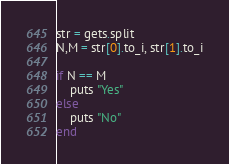Convert code to text. <code><loc_0><loc_0><loc_500><loc_500><_Ruby_>str = gets.split
N,M = str[0].to_i, str[1].to_i

if N == M
    puts "Yes"
else
    puts "No"
end</code> 